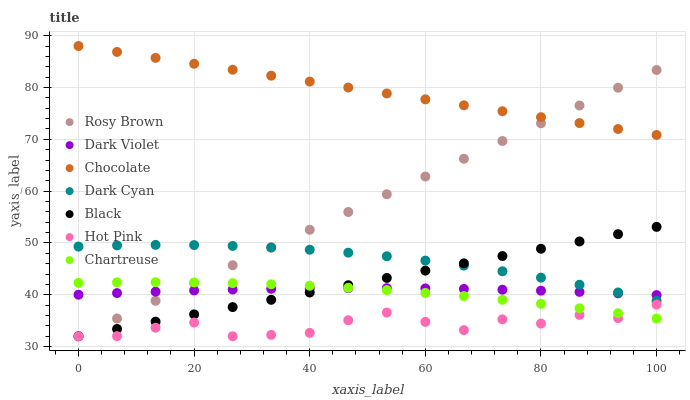Does Hot Pink have the minimum area under the curve?
Answer yes or no. Yes. Does Chocolate have the maximum area under the curve?
Answer yes or no. Yes. Does Dark Violet have the minimum area under the curve?
Answer yes or no. No. Does Dark Violet have the maximum area under the curve?
Answer yes or no. No. Is Black the smoothest?
Answer yes or no. Yes. Is Hot Pink the roughest?
Answer yes or no. Yes. Is Dark Violet the smoothest?
Answer yes or no. No. Is Dark Violet the roughest?
Answer yes or no. No. Does Rosy Brown have the lowest value?
Answer yes or no. Yes. Does Dark Violet have the lowest value?
Answer yes or no. No. Does Chocolate have the highest value?
Answer yes or no. Yes. Does Dark Violet have the highest value?
Answer yes or no. No. Is Hot Pink less than Dark Violet?
Answer yes or no. Yes. Is Chocolate greater than Hot Pink?
Answer yes or no. Yes. Does Chartreuse intersect Dark Violet?
Answer yes or no. Yes. Is Chartreuse less than Dark Violet?
Answer yes or no. No. Is Chartreuse greater than Dark Violet?
Answer yes or no. No. Does Hot Pink intersect Dark Violet?
Answer yes or no. No. 